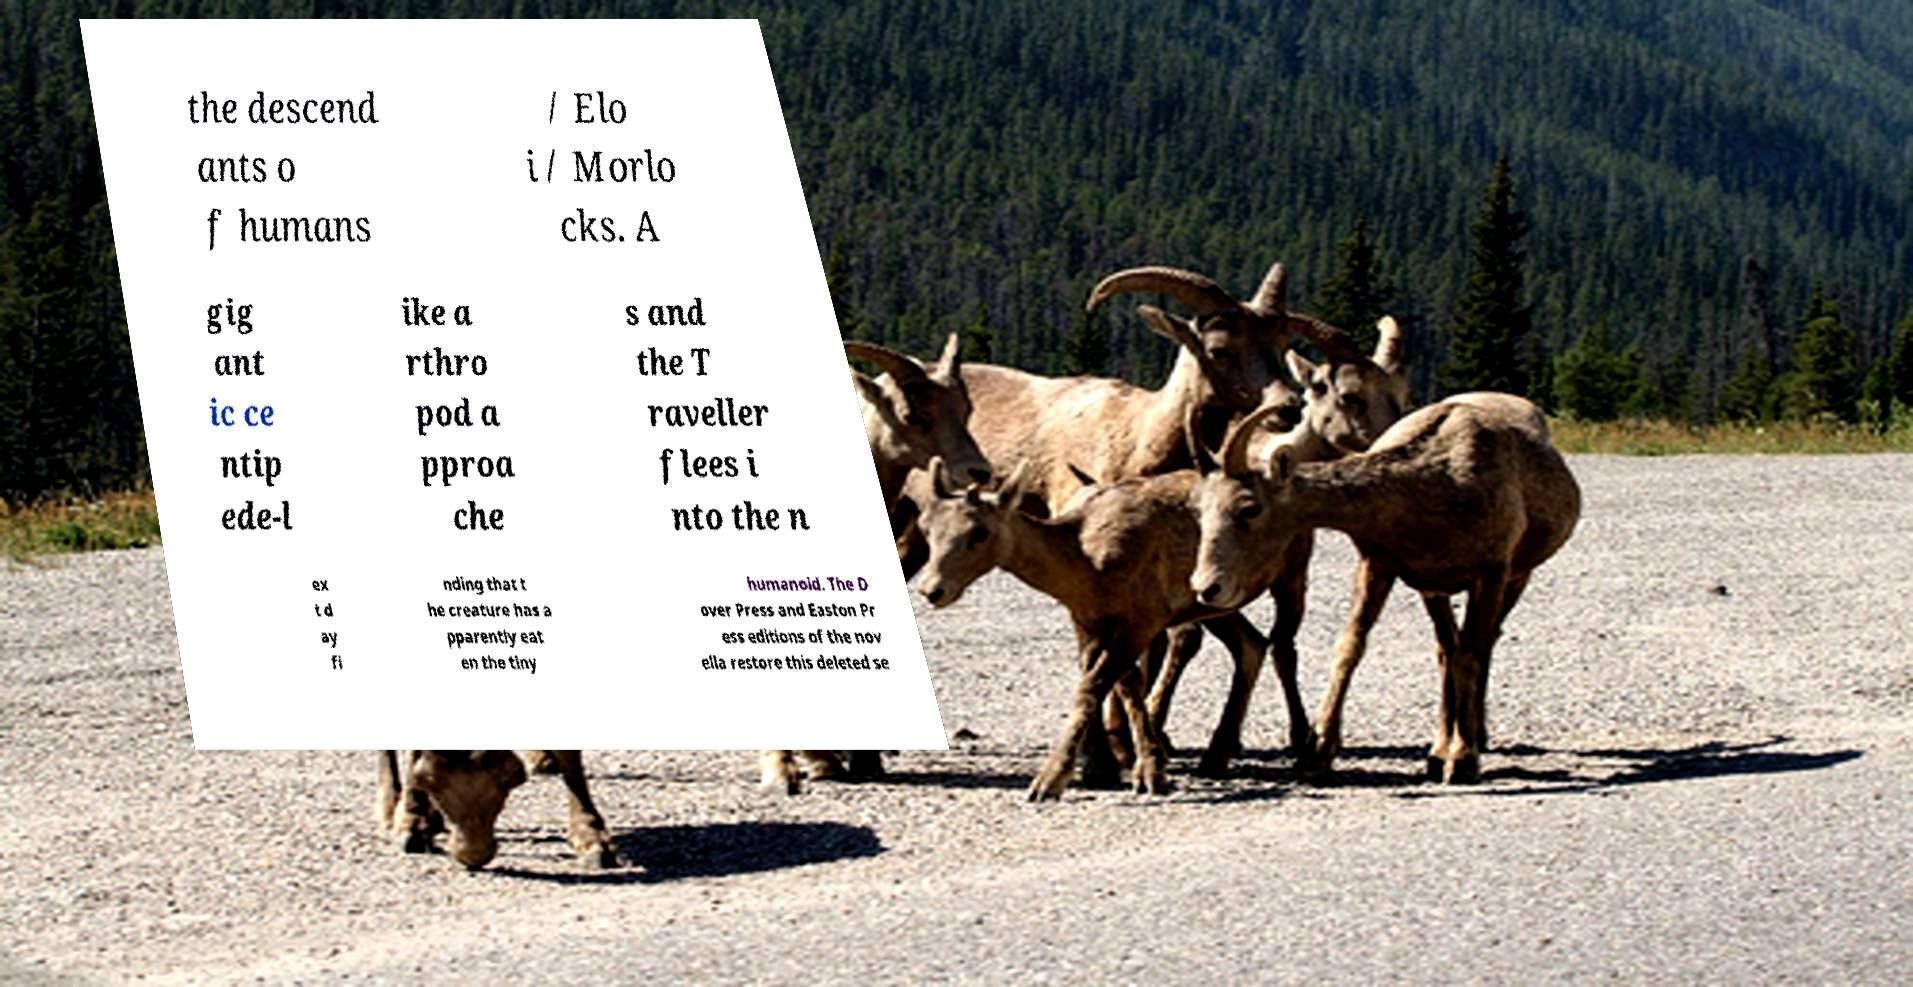I need the written content from this picture converted into text. Can you do that? the descend ants o f humans / Elo i / Morlo cks. A gig ant ic ce ntip ede-l ike a rthro pod a pproa che s and the T raveller flees i nto the n ex t d ay fi nding that t he creature has a pparently eat en the tiny humanoid. The D over Press and Easton Pr ess editions of the nov ella restore this deleted se 